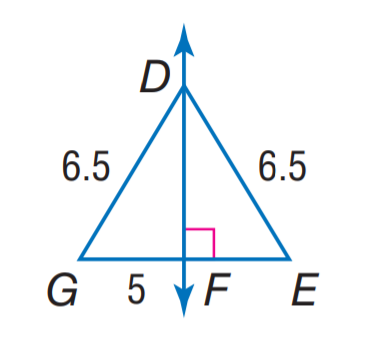Answer the mathemtical geometry problem and directly provide the correct option letter.
Question: Find E G.
Choices: A: 5 B: 6.5 C: 10 D: 13 C 